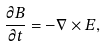Convert formula to latex. <formula><loc_0><loc_0><loc_500><loc_500>\frac { \partial \vec { B } } { \partial t } = - \nabla \times \vec { E } ,</formula> 